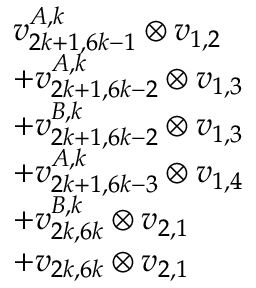Convert formula to latex. <formula><loc_0><loc_0><loc_500><loc_500>\begin{array} { r l } & { v _ { 2 k + 1 , 6 k - 1 } ^ { A , k } \otimes v _ { 1 , 2 } } \\ & { + v _ { 2 k + 1 , 6 k - 2 } ^ { A , k } \otimes v _ { 1 , 3 } } \\ & { + v _ { 2 k + 1 , 6 k - 2 } ^ { B , k } \otimes v _ { 1 , 3 } } \\ & { + v _ { 2 k + 1 , 6 k - 3 } ^ { A , k } \otimes v _ { 1 , 4 } } \\ & { + v _ { 2 k , 6 k } ^ { B , k } \otimes v _ { 2 , 1 } } \\ & { + v _ { 2 k , 6 k } \otimes v _ { 2 , 1 } } \end{array}</formula> 